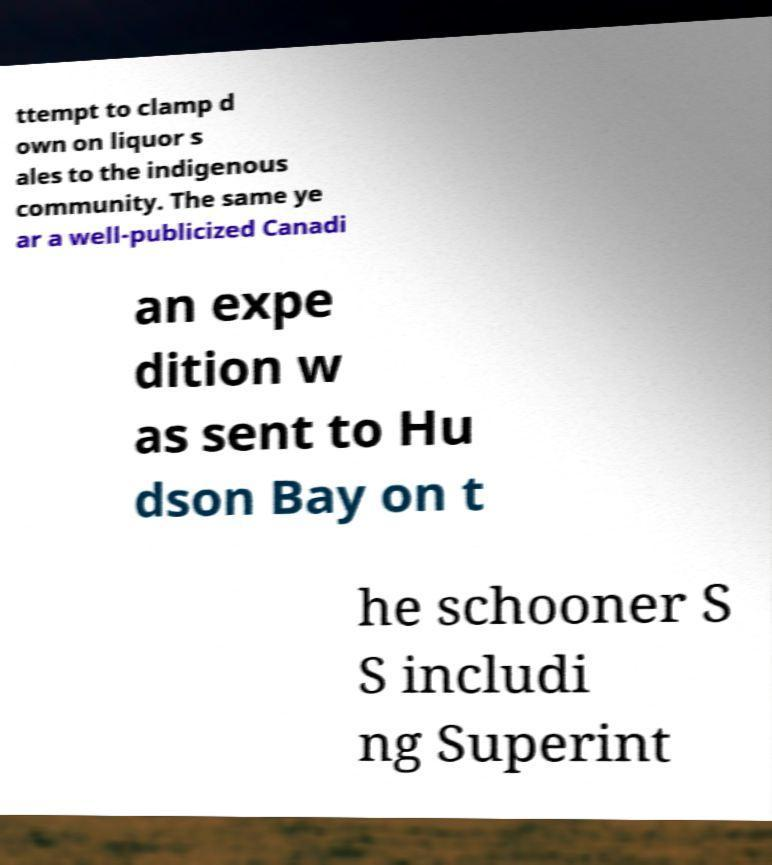There's text embedded in this image that I need extracted. Can you transcribe it verbatim? ttempt to clamp d own on liquor s ales to the indigenous community. The same ye ar a well-publicized Canadi an expe dition w as sent to Hu dson Bay on t he schooner S S includi ng Superint 